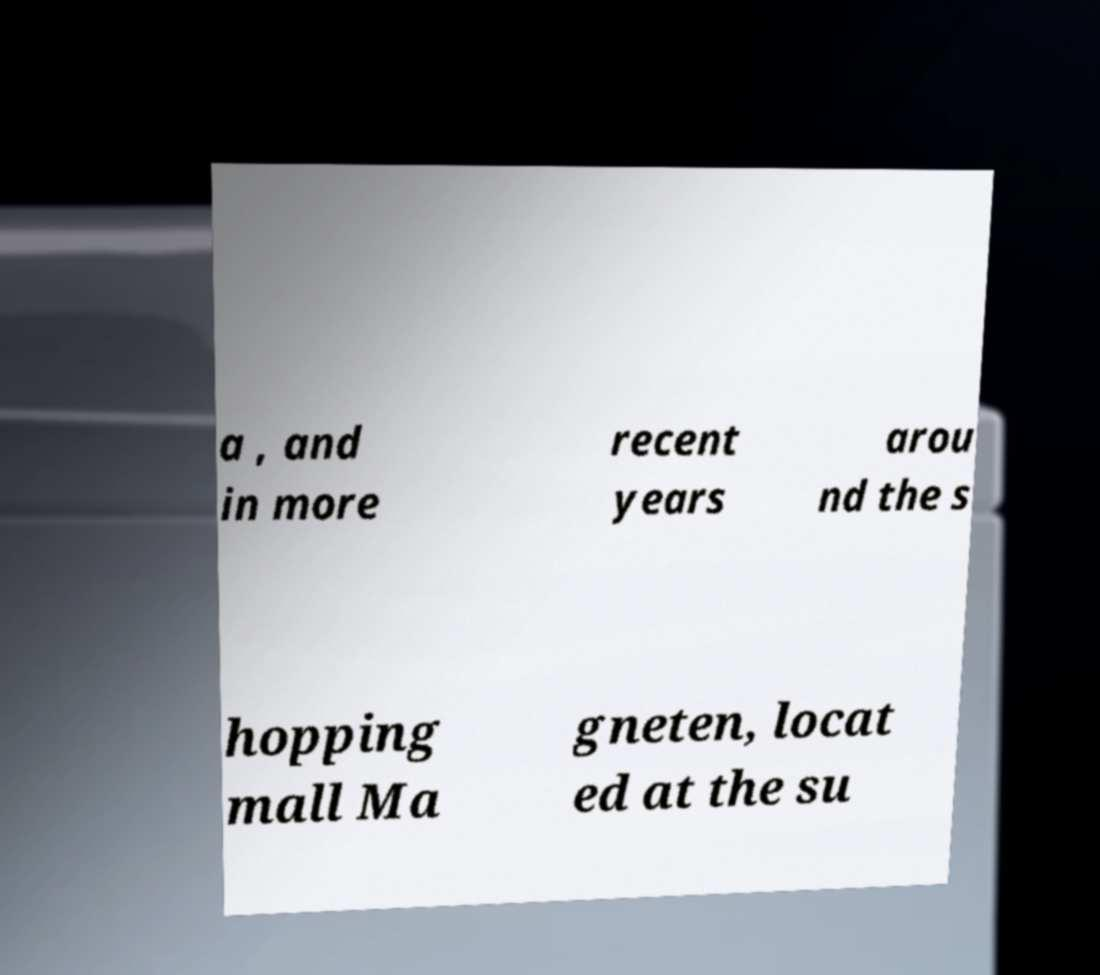Can you accurately transcribe the text from the provided image for me? a , and in more recent years arou nd the s hopping mall Ma gneten, locat ed at the su 